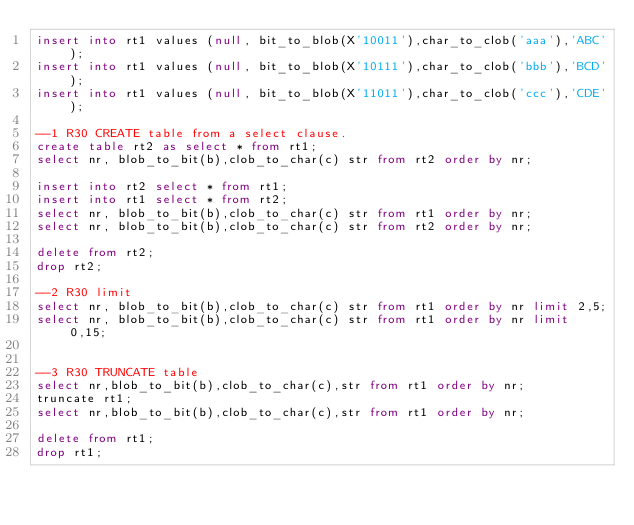Convert code to text. <code><loc_0><loc_0><loc_500><loc_500><_SQL_>insert into rt1 values (null, bit_to_blob(X'10011'),char_to_clob('aaa'),'ABC');
insert into rt1 values (null, bit_to_blob(X'10111'),char_to_clob('bbb'),'BCD');
insert into rt1 values (null, bit_to_blob(X'11011'),char_to_clob('ccc'),'CDE');

--1 R30 CREATE table from a select clause.
create table rt2 as select * from rt1;
select nr, blob_to_bit(b),clob_to_char(c) str from rt2 order by nr;

insert into rt2 select * from rt1;
insert into rt1 select * from rt2;
select nr, blob_to_bit(b),clob_to_char(c) str from rt1 order by nr;
select nr, blob_to_bit(b),clob_to_char(c) str from rt2 order by nr;

delete from rt2;
drop rt2;

--2 R30	limit
select nr, blob_to_bit(b),clob_to_char(c) str from rt1 order by nr limit 2,5;
select nr, blob_to_bit(b),clob_to_char(c) str from rt1 order by nr limit 0,15;


--3 R30 TRUNCATE table
select nr,blob_to_bit(b),clob_to_char(c),str from rt1 order by nr;
truncate rt1;
select nr,blob_to_bit(b),clob_to_char(c),str from rt1 order by nr;

delete from rt1;
drop rt1;
</code> 